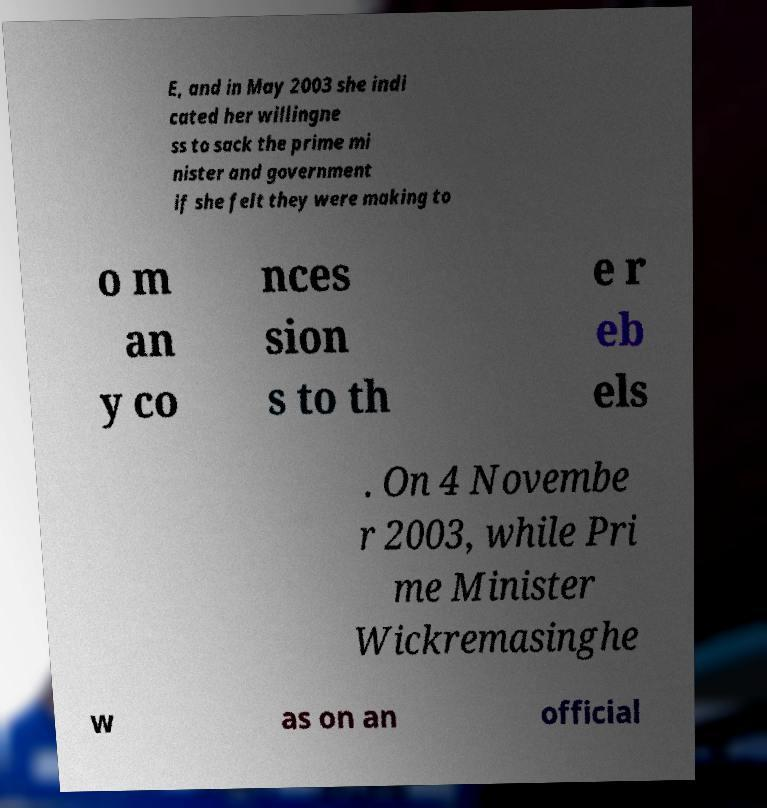Could you assist in decoding the text presented in this image and type it out clearly? E, and in May 2003 she indi cated her willingne ss to sack the prime mi nister and government if she felt they were making to o m an y co nces sion s to th e r eb els . On 4 Novembe r 2003, while Pri me Minister Wickremasinghe w as on an official 